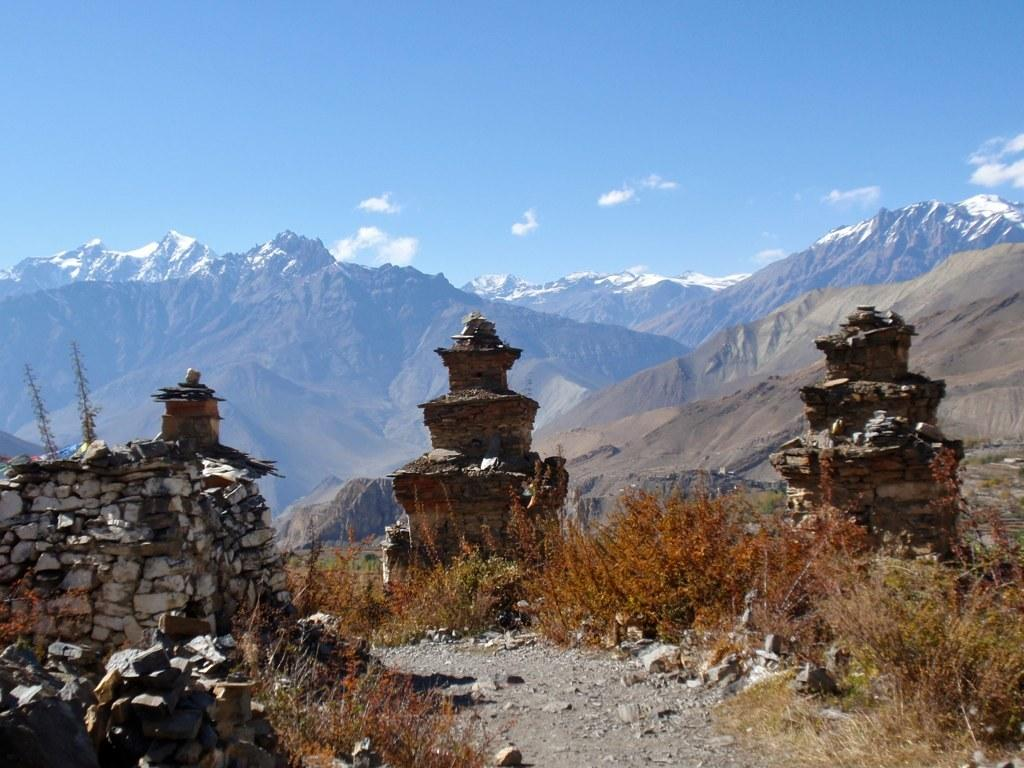What type of objects are made of rocks in the image? There are objects made of rocks in the image, but the specific type is not mentioned. What other natural elements are present near the rock objects? There are plants beside the rock objects. What can be seen in the distance in the image? There are mountains visible in the background of the image. What type of mask is being worn by the person in the image? There is no person or mask present in the image; it features rock objects and plants. Can you tell me what card game is being played in the image? There is no card game or cards present in the image; it features rock objects, plants, and mountains. 